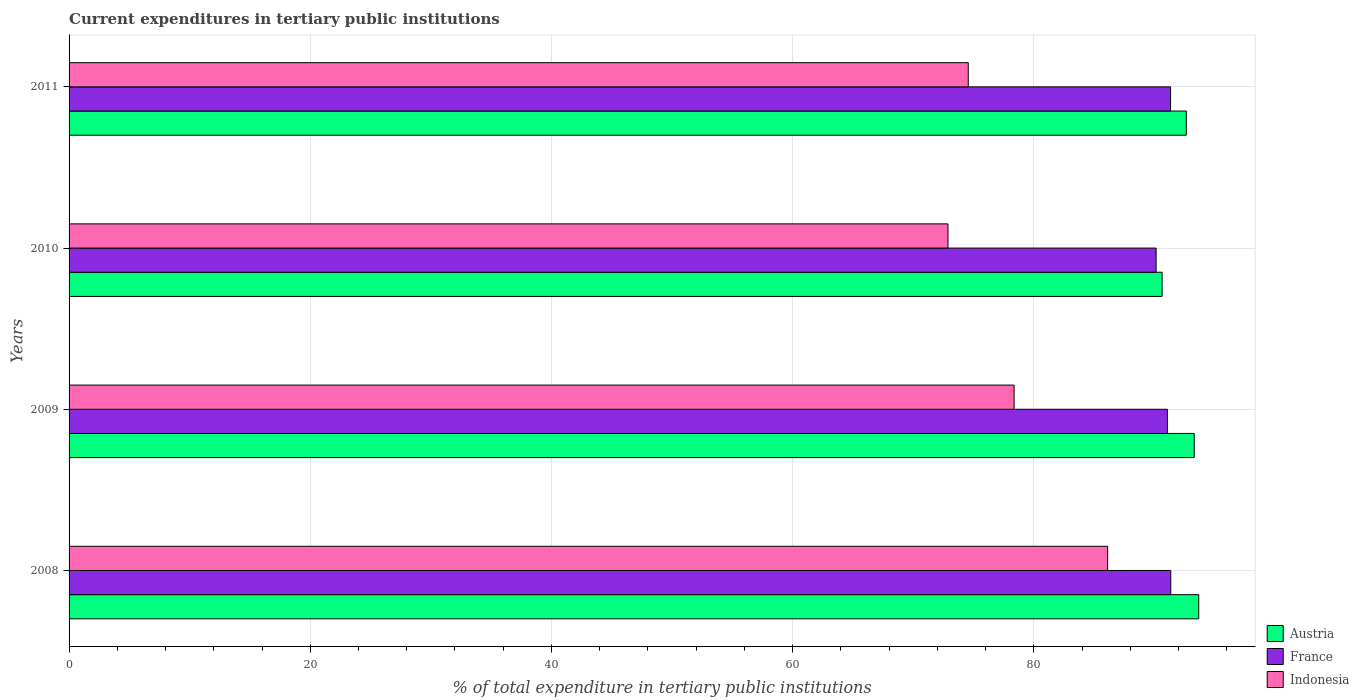How many groups of bars are there?
Offer a terse response. 4. Are the number of bars per tick equal to the number of legend labels?
Ensure brevity in your answer.  Yes. Are the number of bars on each tick of the Y-axis equal?
Provide a short and direct response. Yes. How many bars are there on the 3rd tick from the top?
Offer a terse response. 3. How many bars are there on the 3rd tick from the bottom?
Provide a short and direct response. 3. What is the current expenditures in tertiary public institutions in Austria in 2010?
Provide a succinct answer. 90.64. Across all years, what is the maximum current expenditures in tertiary public institutions in Austria?
Your answer should be very brief. 93.68. Across all years, what is the minimum current expenditures in tertiary public institutions in Indonesia?
Provide a short and direct response. 72.88. What is the total current expenditures in tertiary public institutions in Austria in the graph?
Provide a short and direct response. 370.26. What is the difference between the current expenditures in tertiary public institutions in Indonesia in 2009 and that in 2010?
Offer a very short reply. 5.48. What is the difference between the current expenditures in tertiary public institutions in France in 2011 and the current expenditures in tertiary public institutions in Indonesia in 2008?
Keep it short and to the point. 5.22. What is the average current expenditures in tertiary public institutions in Indonesia per year?
Your answer should be compact. 77.98. In the year 2009, what is the difference between the current expenditures in tertiary public institutions in France and current expenditures in tertiary public institutions in Austria?
Provide a short and direct response. -2.23. In how many years, is the current expenditures in tertiary public institutions in France greater than 80 %?
Provide a succinct answer. 4. What is the ratio of the current expenditures in tertiary public institutions in Indonesia in 2008 to that in 2011?
Give a very brief answer. 1.16. What is the difference between the highest and the second highest current expenditures in tertiary public institutions in Indonesia?
Offer a terse response. 7.76. What is the difference between the highest and the lowest current expenditures in tertiary public institutions in Indonesia?
Your answer should be compact. 13.24. What does the 3rd bar from the top in 2009 represents?
Give a very brief answer. Austria. Is it the case that in every year, the sum of the current expenditures in tertiary public institutions in Austria and current expenditures in tertiary public institutions in France is greater than the current expenditures in tertiary public institutions in Indonesia?
Provide a succinct answer. Yes. How many bars are there?
Give a very brief answer. 12. Are all the bars in the graph horizontal?
Give a very brief answer. Yes. What is the difference between two consecutive major ticks on the X-axis?
Your response must be concise. 20. Are the values on the major ticks of X-axis written in scientific E-notation?
Provide a succinct answer. No. How many legend labels are there?
Provide a short and direct response. 3. How are the legend labels stacked?
Provide a short and direct response. Vertical. What is the title of the graph?
Keep it short and to the point. Current expenditures in tertiary public institutions. Does "St. Vincent and the Grenadines" appear as one of the legend labels in the graph?
Provide a succinct answer. No. What is the label or title of the X-axis?
Ensure brevity in your answer.  % of total expenditure in tertiary public institutions. What is the % of total expenditure in tertiary public institutions in Austria in 2008?
Offer a very short reply. 93.68. What is the % of total expenditure in tertiary public institutions of France in 2008?
Provide a succinct answer. 91.36. What is the % of total expenditure in tertiary public institutions in Indonesia in 2008?
Offer a very short reply. 86.12. What is the % of total expenditure in tertiary public institutions in Austria in 2009?
Make the answer very short. 93.3. What is the % of total expenditure in tertiary public institutions in France in 2009?
Your answer should be compact. 91.08. What is the % of total expenditure in tertiary public institutions of Indonesia in 2009?
Give a very brief answer. 78.37. What is the % of total expenditure in tertiary public institutions of Austria in 2010?
Provide a short and direct response. 90.64. What is the % of total expenditure in tertiary public institutions in France in 2010?
Your answer should be compact. 90.14. What is the % of total expenditure in tertiary public institutions of Indonesia in 2010?
Provide a short and direct response. 72.88. What is the % of total expenditure in tertiary public institutions of Austria in 2011?
Keep it short and to the point. 92.65. What is the % of total expenditure in tertiary public institutions of France in 2011?
Offer a very short reply. 91.34. What is the % of total expenditure in tertiary public institutions of Indonesia in 2011?
Keep it short and to the point. 74.56. Across all years, what is the maximum % of total expenditure in tertiary public institutions in Austria?
Ensure brevity in your answer.  93.68. Across all years, what is the maximum % of total expenditure in tertiary public institutions of France?
Offer a terse response. 91.36. Across all years, what is the maximum % of total expenditure in tertiary public institutions in Indonesia?
Provide a short and direct response. 86.12. Across all years, what is the minimum % of total expenditure in tertiary public institutions of Austria?
Offer a terse response. 90.64. Across all years, what is the minimum % of total expenditure in tertiary public institutions in France?
Ensure brevity in your answer.  90.14. Across all years, what is the minimum % of total expenditure in tertiary public institutions in Indonesia?
Keep it short and to the point. 72.88. What is the total % of total expenditure in tertiary public institutions in Austria in the graph?
Provide a short and direct response. 370.26. What is the total % of total expenditure in tertiary public institutions of France in the graph?
Provide a succinct answer. 363.91. What is the total % of total expenditure in tertiary public institutions in Indonesia in the graph?
Provide a succinct answer. 311.93. What is the difference between the % of total expenditure in tertiary public institutions in Austria in 2008 and that in 2009?
Make the answer very short. 0.37. What is the difference between the % of total expenditure in tertiary public institutions of France in 2008 and that in 2009?
Give a very brief answer. 0.28. What is the difference between the % of total expenditure in tertiary public institutions in Indonesia in 2008 and that in 2009?
Your answer should be very brief. 7.76. What is the difference between the % of total expenditure in tertiary public institutions of Austria in 2008 and that in 2010?
Your response must be concise. 3.04. What is the difference between the % of total expenditure in tertiary public institutions of France in 2008 and that in 2010?
Your answer should be compact. 1.21. What is the difference between the % of total expenditure in tertiary public institutions in Indonesia in 2008 and that in 2010?
Your answer should be very brief. 13.24. What is the difference between the % of total expenditure in tertiary public institutions in Austria in 2008 and that in 2011?
Your response must be concise. 1.03. What is the difference between the % of total expenditure in tertiary public institutions in France in 2008 and that in 2011?
Give a very brief answer. 0.02. What is the difference between the % of total expenditure in tertiary public institutions in Indonesia in 2008 and that in 2011?
Give a very brief answer. 11.56. What is the difference between the % of total expenditure in tertiary public institutions of Austria in 2009 and that in 2010?
Make the answer very short. 2.66. What is the difference between the % of total expenditure in tertiary public institutions in France in 2009 and that in 2010?
Your answer should be compact. 0.93. What is the difference between the % of total expenditure in tertiary public institutions of Indonesia in 2009 and that in 2010?
Make the answer very short. 5.48. What is the difference between the % of total expenditure in tertiary public institutions of Austria in 2009 and that in 2011?
Provide a succinct answer. 0.66. What is the difference between the % of total expenditure in tertiary public institutions in France in 2009 and that in 2011?
Your answer should be very brief. -0.26. What is the difference between the % of total expenditure in tertiary public institutions in Indonesia in 2009 and that in 2011?
Give a very brief answer. 3.8. What is the difference between the % of total expenditure in tertiary public institutions in Austria in 2010 and that in 2011?
Your answer should be compact. -2.01. What is the difference between the % of total expenditure in tertiary public institutions in France in 2010 and that in 2011?
Give a very brief answer. -1.19. What is the difference between the % of total expenditure in tertiary public institutions of Indonesia in 2010 and that in 2011?
Offer a very short reply. -1.68. What is the difference between the % of total expenditure in tertiary public institutions in Austria in 2008 and the % of total expenditure in tertiary public institutions in France in 2009?
Ensure brevity in your answer.  2.6. What is the difference between the % of total expenditure in tertiary public institutions in Austria in 2008 and the % of total expenditure in tertiary public institutions in Indonesia in 2009?
Make the answer very short. 15.31. What is the difference between the % of total expenditure in tertiary public institutions in France in 2008 and the % of total expenditure in tertiary public institutions in Indonesia in 2009?
Provide a succinct answer. 12.99. What is the difference between the % of total expenditure in tertiary public institutions in Austria in 2008 and the % of total expenditure in tertiary public institutions in France in 2010?
Provide a succinct answer. 3.53. What is the difference between the % of total expenditure in tertiary public institutions in Austria in 2008 and the % of total expenditure in tertiary public institutions in Indonesia in 2010?
Make the answer very short. 20.79. What is the difference between the % of total expenditure in tertiary public institutions in France in 2008 and the % of total expenditure in tertiary public institutions in Indonesia in 2010?
Keep it short and to the point. 18.47. What is the difference between the % of total expenditure in tertiary public institutions in Austria in 2008 and the % of total expenditure in tertiary public institutions in France in 2011?
Provide a short and direct response. 2.34. What is the difference between the % of total expenditure in tertiary public institutions of Austria in 2008 and the % of total expenditure in tertiary public institutions of Indonesia in 2011?
Your answer should be compact. 19.11. What is the difference between the % of total expenditure in tertiary public institutions in France in 2008 and the % of total expenditure in tertiary public institutions in Indonesia in 2011?
Your answer should be compact. 16.79. What is the difference between the % of total expenditure in tertiary public institutions of Austria in 2009 and the % of total expenditure in tertiary public institutions of France in 2010?
Ensure brevity in your answer.  3.16. What is the difference between the % of total expenditure in tertiary public institutions of Austria in 2009 and the % of total expenditure in tertiary public institutions of Indonesia in 2010?
Offer a terse response. 20.42. What is the difference between the % of total expenditure in tertiary public institutions in France in 2009 and the % of total expenditure in tertiary public institutions in Indonesia in 2010?
Keep it short and to the point. 18.19. What is the difference between the % of total expenditure in tertiary public institutions of Austria in 2009 and the % of total expenditure in tertiary public institutions of France in 2011?
Keep it short and to the point. 1.97. What is the difference between the % of total expenditure in tertiary public institutions of Austria in 2009 and the % of total expenditure in tertiary public institutions of Indonesia in 2011?
Your answer should be very brief. 18.74. What is the difference between the % of total expenditure in tertiary public institutions of France in 2009 and the % of total expenditure in tertiary public institutions of Indonesia in 2011?
Ensure brevity in your answer.  16.51. What is the difference between the % of total expenditure in tertiary public institutions in Austria in 2010 and the % of total expenditure in tertiary public institutions in France in 2011?
Make the answer very short. -0.7. What is the difference between the % of total expenditure in tertiary public institutions in Austria in 2010 and the % of total expenditure in tertiary public institutions in Indonesia in 2011?
Offer a terse response. 16.08. What is the difference between the % of total expenditure in tertiary public institutions in France in 2010 and the % of total expenditure in tertiary public institutions in Indonesia in 2011?
Provide a succinct answer. 15.58. What is the average % of total expenditure in tertiary public institutions of Austria per year?
Your answer should be compact. 92.57. What is the average % of total expenditure in tertiary public institutions of France per year?
Your response must be concise. 90.98. What is the average % of total expenditure in tertiary public institutions in Indonesia per year?
Your response must be concise. 77.98. In the year 2008, what is the difference between the % of total expenditure in tertiary public institutions of Austria and % of total expenditure in tertiary public institutions of France?
Make the answer very short. 2.32. In the year 2008, what is the difference between the % of total expenditure in tertiary public institutions in Austria and % of total expenditure in tertiary public institutions in Indonesia?
Give a very brief answer. 7.55. In the year 2008, what is the difference between the % of total expenditure in tertiary public institutions of France and % of total expenditure in tertiary public institutions of Indonesia?
Give a very brief answer. 5.24. In the year 2009, what is the difference between the % of total expenditure in tertiary public institutions in Austria and % of total expenditure in tertiary public institutions in France?
Your answer should be very brief. 2.23. In the year 2009, what is the difference between the % of total expenditure in tertiary public institutions of Austria and % of total expenditure in tertiary public institutions of Indonesia?
Provide a short and direct response. 14.94. In the year 2009, what is the difference between the % of total expenditure in tertiary public institutions in France and % of total expenditure in tertiary public institutions in Indonesia?
Ensure brevity in your answer.  12.71. In the year 2010, what is the difference between the % of total expenditure in tertiary public institutions in Austria and % of total expenditure in tertiary public institutions in France?
Give a very brief answer. 0.5. In the year 2010, what is the difference between the % of total expenditure in tertiary public institutions in Austria and % of total expenditure in tertiary public institutions in Indonesia?
Your response must be concise. 17.76. In the year 2010, what is the difference between the % of total expenditure in tertiary public institutions in France and % of total expenditure in tertiary public institutions in Indonesia?
Keep it short and to the point. 17.26. In the year 2011, what is the difference between the % of total expenditure in tertiary public institutions of Austria and % of total expenditure in tertiary public institutions of France?
Your answer should be very brief. 1.31. In the year 2011, what is the difference between the % of total expenditure in tertiary public institutions in Austria and % of total expenditure in tertiary public institutions in Indonesia?
Provide a succinct answer. 18.08. In the year 2011, what is the difference between the % of total expenditure in tertiary public institutions of France and % of total expenditure in tertiary public institutions of Indonesia?
Make the answer very short. 16.77. What is the ratio of the % of total expenditure in tertiary public institutions in Austria in 2008 to that in 2009?
Your response must be concise. 1. What is the ratio of the % of total expenditure in tertiary public institutions in France in 2008 to that in 2009?
Offer a very short reply. 1. What is the ratio of the % of total expenditure in tertiary public institutions of Indonesia in 2008 to that in 2009?
Provide a short and direct response. 1.1. What is the ratio of the % of total expenditure in tertiary public institutions of Austria in 2008 to that in 2010?
Give a very brief answer. 1.03. What is the ratio of the % of total expenditure in tertiary public institutions of France in 2008 to that in 2010?
Make the answer very short. 1.01. What is the ratio of the % of total expenditure in tertiary public institutions in Indonesia in 2008 to that in 2010?
Offer a very short reply. 1.18. What is the ratio of the % of total expenditure in tertiary public institutions in Austria in 2008 to that in 2011?
Give a very brief answer. 1.01. What is the ratio of the % of total expenditure in tertiary public institutions in Indonesia in 2008 to that in 2011?
Your answer should be very brief. 1.16. What is the ratio of the % of total expenditure in tertiary public institutions in Austria in 2009 to that in 2010?
Provide a short and direct response. 1.03. What is the ratio of the % of total expenditure in tertiary public institutions of France in 2009 to that in 2010?
Give a very brief answer. 1.01. What is the ratio of the % of total expenditure in tertiary public institutions in Indonesia in 2009 to that in 2010?
Give a very brief answer. 1.08. What is the ratio of the % of total expenditure in tertiary public institutions of Austria in 2009 to that in 2011?
Keep it short and to the point. 1.01. What is the ratio of the % of total expenditure in tertiary public institutions in Indonesia in 2009 to that in 2011?
Provide a succinct answer. 1.05. What is the ratio of the % of total expenditure in tertiary public institutions of Austria in 2010 to that in 2011?
Ensure brevity in your answer.  0.98. What is the ratio of the % of total expenditure in tertiary public institutions in France in 2010 to that in 2011?
Make the answer very short. 0.99. What is the ratio of the % of total expenditure in tertiary public institutions in Indonesia in 2010 to that in 2011?
Ensure brevity in your answer.  0.98. What is the difference between the highest and the second highest % of total expenditure in tertiary public institutions in Austria?
Provide a short and direct response. 0.37. What is the difference between the highest and the second highest % of total expenditure in tertiary public institutions in France?
Make the answer very short. 0.02. What is the difference between the highest and the second highest % of total expenditure in tertiary public institutions in Indonesia?
Your answer should be very brief. 7.76. What is the difference between the highest and the lowest % of total expenditure in tertiary public institutions of Austria?
Your response must be concise. 3.04. What is the difference between the highest and the lowest % of total expenditure in tertiary public institutions in France?
Ensure brevity in your answer.  1.21. What is the difference between the highest and the lowest % of total expenditure in tertiary public institutions in Indonesia?
Ensure brevity in your answer.  13.24. 